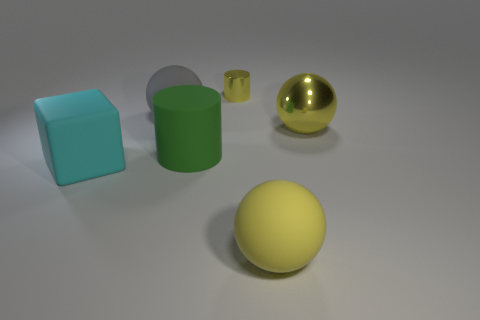Subtract all gray cubes. How many yellow balls are left? 2 Subtract all rubber spheres. How many spheres are left? 1 Add 4 big metal objects. How many objects exist? 10 Subtract all cubes. How many objects are left? 5 Add 6 green rubber cylinders. How many green rubber cylinders exist? 7 Subtract 0 gray cylinders. How many objects are left? 6 Subtract all large yellow rubber balls. Subtract all large green matte cylinders. How many objects are left? 4 Add 6 small yellow cylinders. How many small yellow cylinders are left? 7 